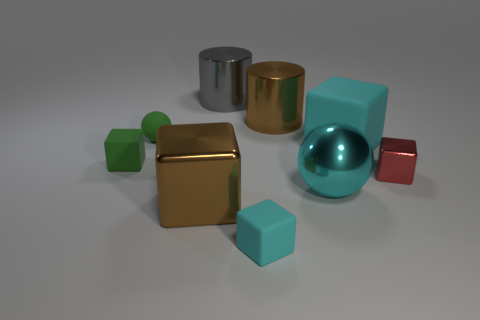There is a large block that is in front of the red object; what color is it? The large block positioned in front of the red object appears to have a shiny, golden surface. Its reflective property adds a touch of elegance to the collection of geometric shapes. 